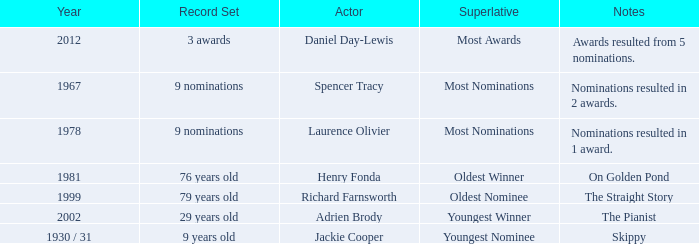What year was the the youngest nominee a winner? 1930 / 31. 